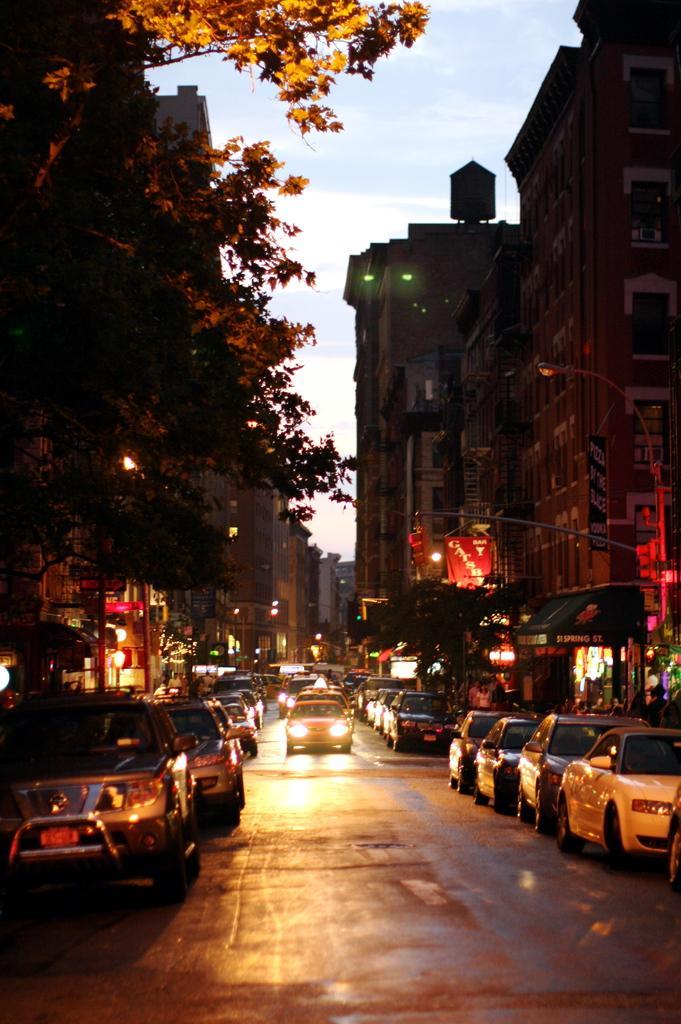How would you summarize this image in a sentence or two? In this image I see the buildings, trees and I see many cars on the road. In the background I see the sky. 